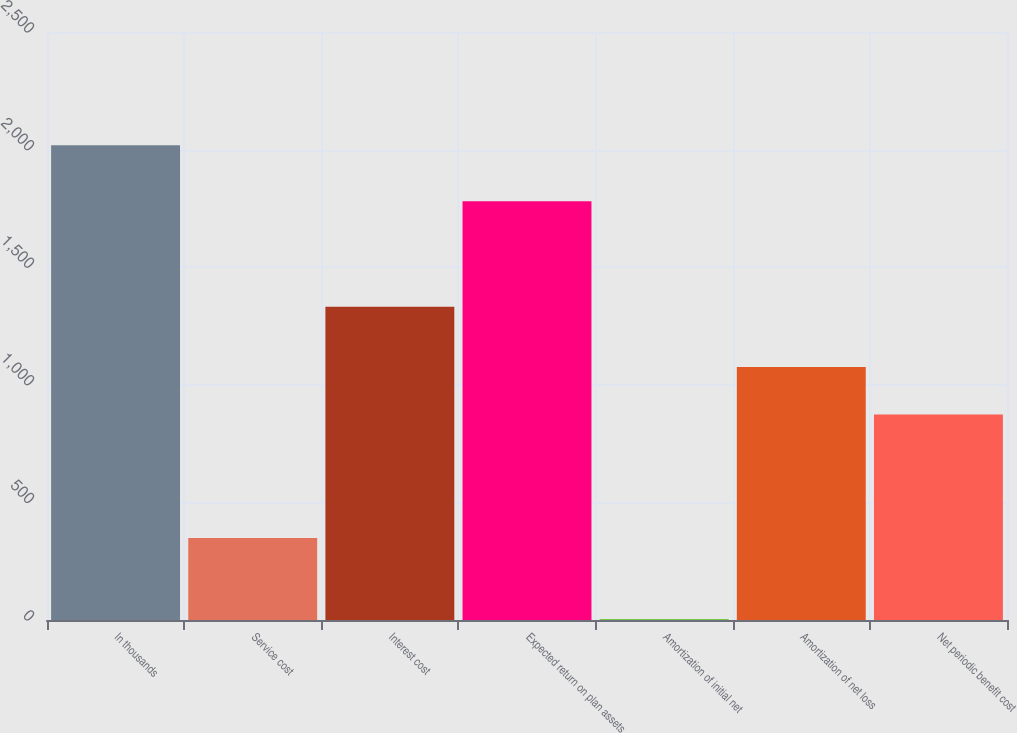Convert chart. <chart><loc_0><loc_0><loc_500><loc_500><bar_chart><fcel>In thousands<fcel>Service cost<fcel>Interest cost<fcel>Expected return on plan assets<fcel>Amortization of initial net<fcel>Amortization of net loss<fcel>Net periodic benefit cost<nl><fcel>2018<fcel>349<fcel>1332<fcel>1780<fcel>3<fcel>1075.5<fcel>874<nl></chart> 